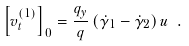Convert formula to latex. <formula><loc_0><loc_0><loc_500><loc_500>\left [ v _ { t } ^ { ( 1 ) } \right ] _ { 0 } = \frac { q _ { y } } { q } \left ( \dot { \gamma } _ { 1 } - \dot { \gamma } _ { 2 } \right ) u \ .</formula> 